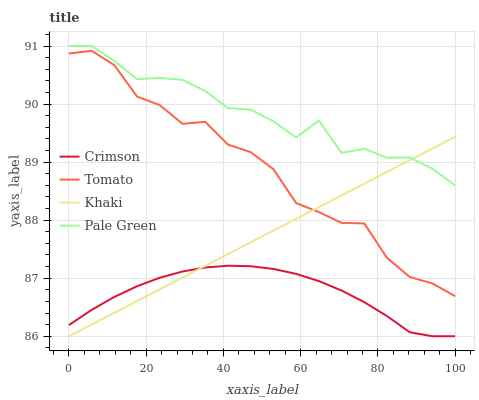Does Crimson have the minimum area under the curve?
Answer yes or no. Yes. Does Pale Green have the maximum area under the curve?
Answer yes or no. Yes. Does Tomato have the minimum area under the curve?
Answer yes or no. No. Does Tomato have the maximum area under the curve?
Answer yes or no. No. Is Khaki the smoothest?
Answer yes or no. Yes. Is Tomato the roughest?
Answer yes or no. Yes. Is Pale Green the smoothest?
Answer yes or no. No. Is Pale Green the roughest?
Answer yes or no. No. Does Tomato have the lowest value?
Answer yes or no. No. Does Pale Green have the highest value?
Answer yes or no. Yes. Does Tomato have the highest value?
Answer yes or no. No. Is Tomato less than Pale Green?
Answer yes or no. Yes. Is Tomato greater than Crimson?
Answer yes or no. Yes. Does Tomato intersect Khaki?
Answer yes or no. Yes. Is Tomato less than Khaki?
Answer yes or no. No. Is Tomato greater than Khaki?
Answer yes or no. No. Does Tomato intersect Pale Green?
Answer yes or no. No. 